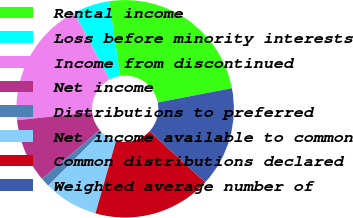<chart> <loc_0><loc_0><loc_500><loc_500><pie_chart><fcel>Rental income<fcel>Loss before minority interests<fcel>Income from discontinued<fcel>Net income<fcel>Distributions to preferred<fcel>Net income available to common<fcel>Common distributions declared<fcel>Weighted average number of<nl><fcel>24.32%<fcel>5.41%<fcel>18.92%<fcel>9.46%<fcel>1.35%<fcel>8.11%<fcel>17.57%<fcel>14.86%<nl></chart> 